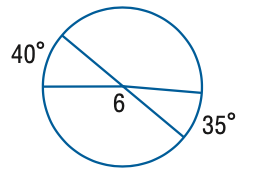Question: Find the measure of \angle 6.
Choices:
A. 130
B. 140
C. 142.5
D. 145
Answer with the letter. Answer: B 